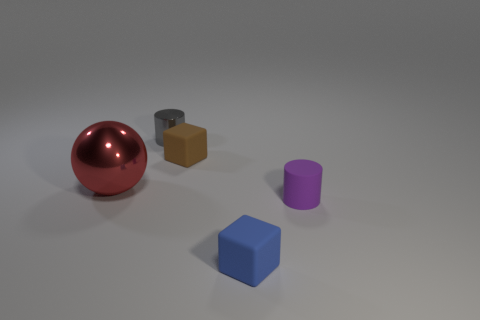There is a gray cylinder; is its size the same as the red metal thing behind the small blue thing?
Offer a very short reply. No. Are there any purple things of the same size as the brown rubber cube?
Keep it short and to the point. Yes. How many things are small rubber cubes or gray metallic things?
Ensure brevity in your answer.  3. Do the block on the right side of the brown block and the thing left of the metal cylinder have the same size?
Make the answer very short. No. Are there any other rubber objects of the same shape as the small blue rubber thing?
Keep it short and to the point. Yes. Is the number of tiny brown things that are right of the small blue block less than the number of things?
Your response must be concise. Yes. Does the tiny metal thing have the same shape as the big red metal thing?
Give a very brief answer. No. What is the size of the blue rubber cube that is on the right side of the tiny gray shiny cylinder?
Your answer should be compact. Small. There is a brown object that is the same material as the tiny blue block; what size is it?
Offer a very short reply. Small. Is the number of gray cylinders less than the number of small green spheres?
Provide a short and direct response. No. 